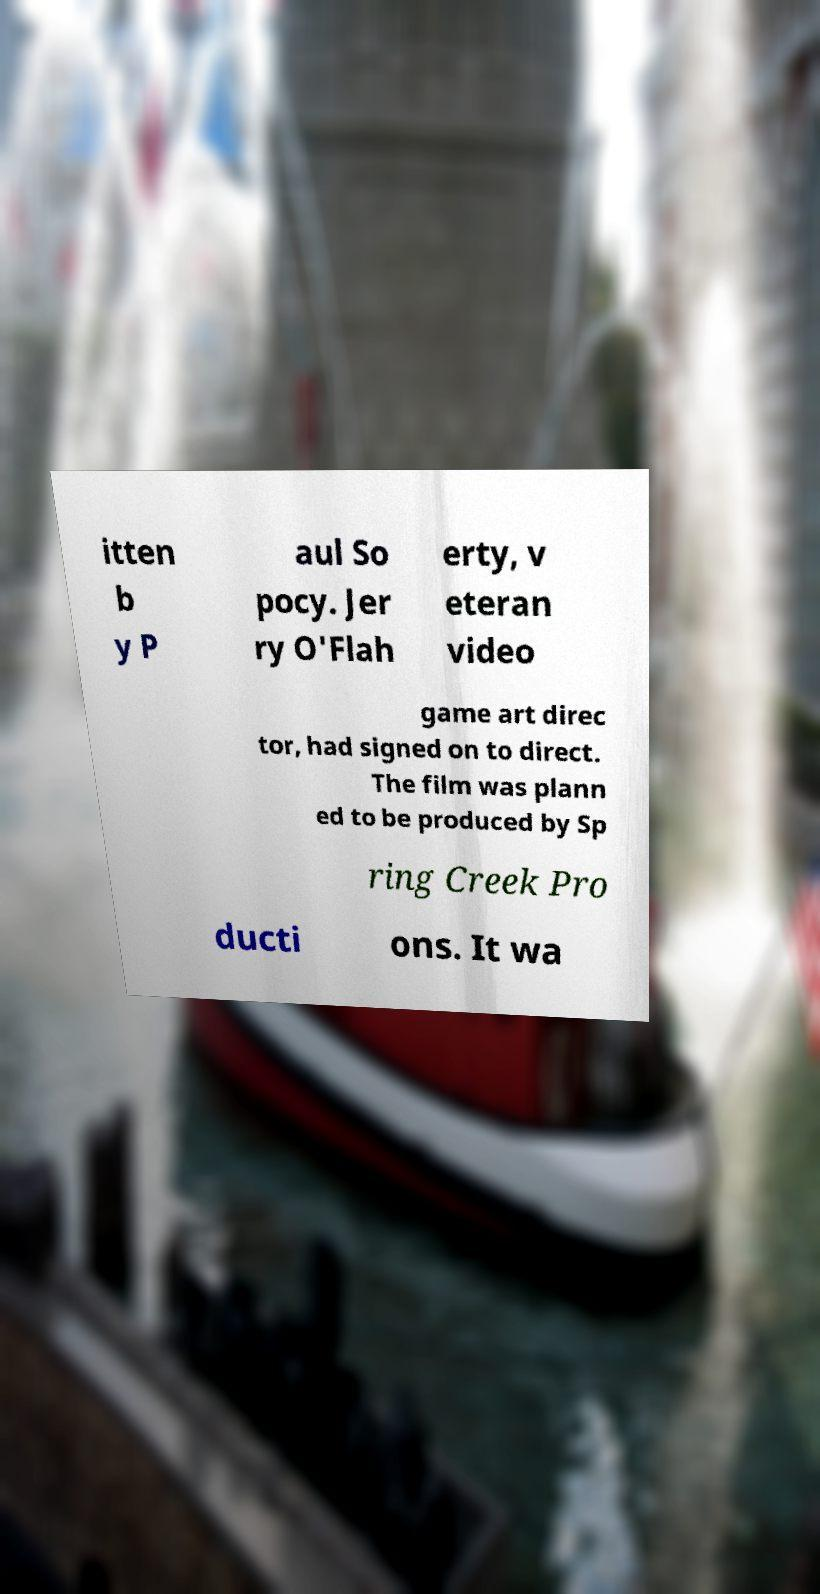Please identify and transcribe the text found in this image. itten b y P aul So pocy. Jer ry O'Flah erty, v eteran video game art direc tor, had signed on to direct. The film was plann ed to be produced by Sp ring Creek Pro ducti ons. It wa 